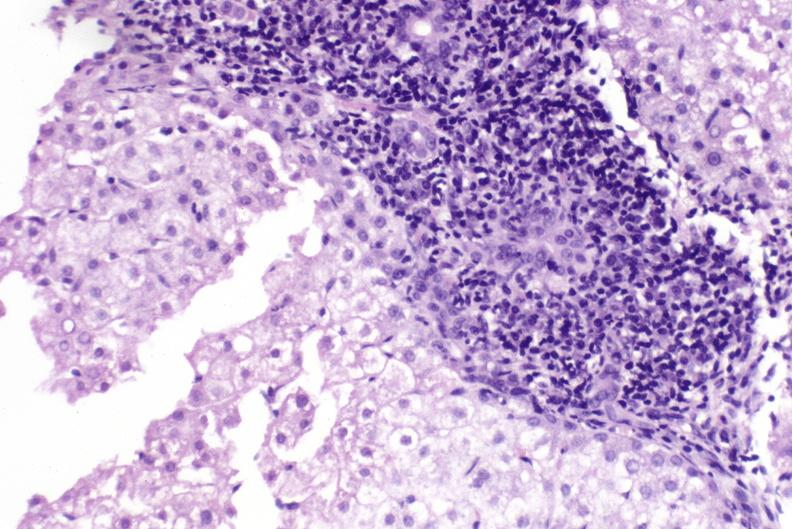s stress present?
Answer the question using a single word or phrase. No 